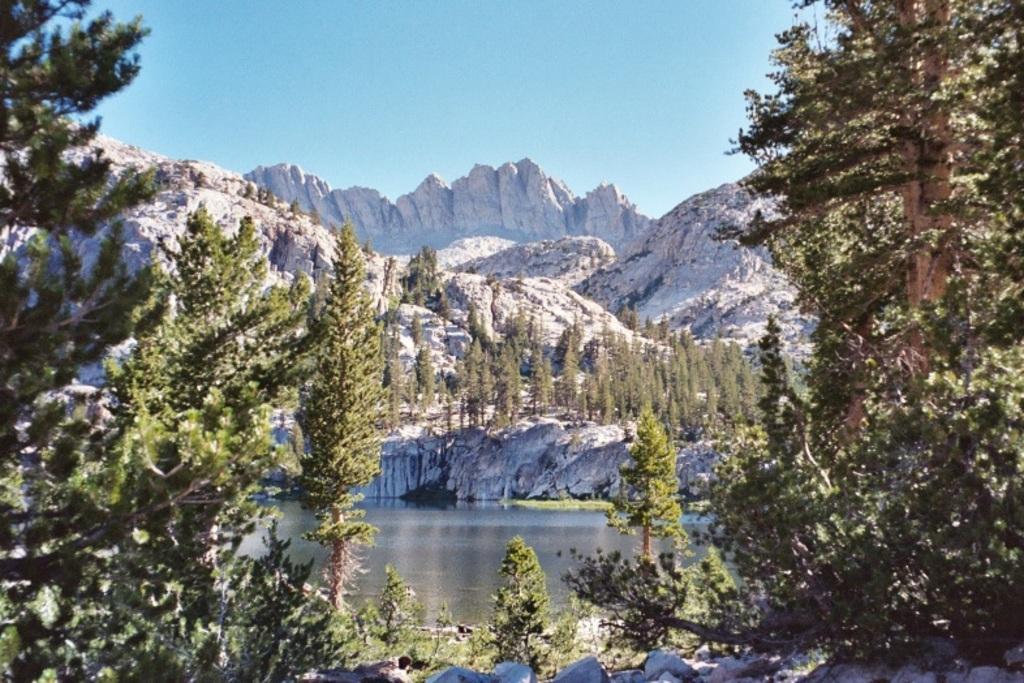Could you give a brief overview of what you see in this image? In this image we can see mountains, trees, water and sky. 